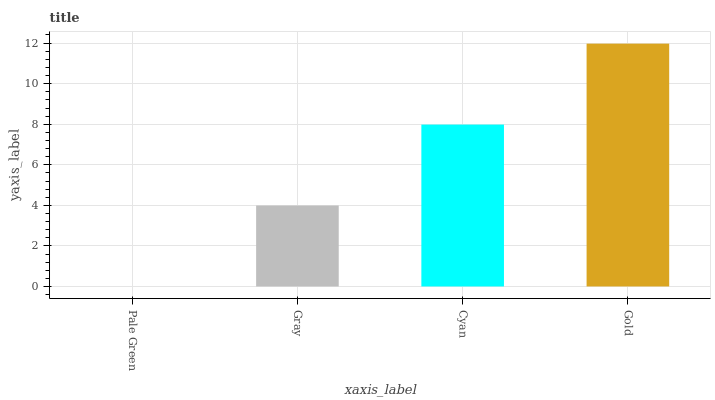Is Pale Green the minimum?
Answer yes or no. Yes. Is Gold the maximum?
Answer yes or no. Yes. Is Gray the minimum?
Answer yes or no. No. Is Gray the maximum?
Answer yes or no. No. Is Gray greater than Pale Green?
Answer yes or no. Yes. Is Pale Green less than Gray?
Answer yes or no. Yes. Is Pale Green greater than Gray?
Answer yes or no. No. Is Gray less than Pale Green?
Answer yes or no. No. Is Cyan the high median?
Answer yes or no. Yes. Is Gray the low median?
Answer yes or no. Yes. Is Gold the high median?
Answer yes or no. No. Is Gold the low median?
Answer yes or no. No. 